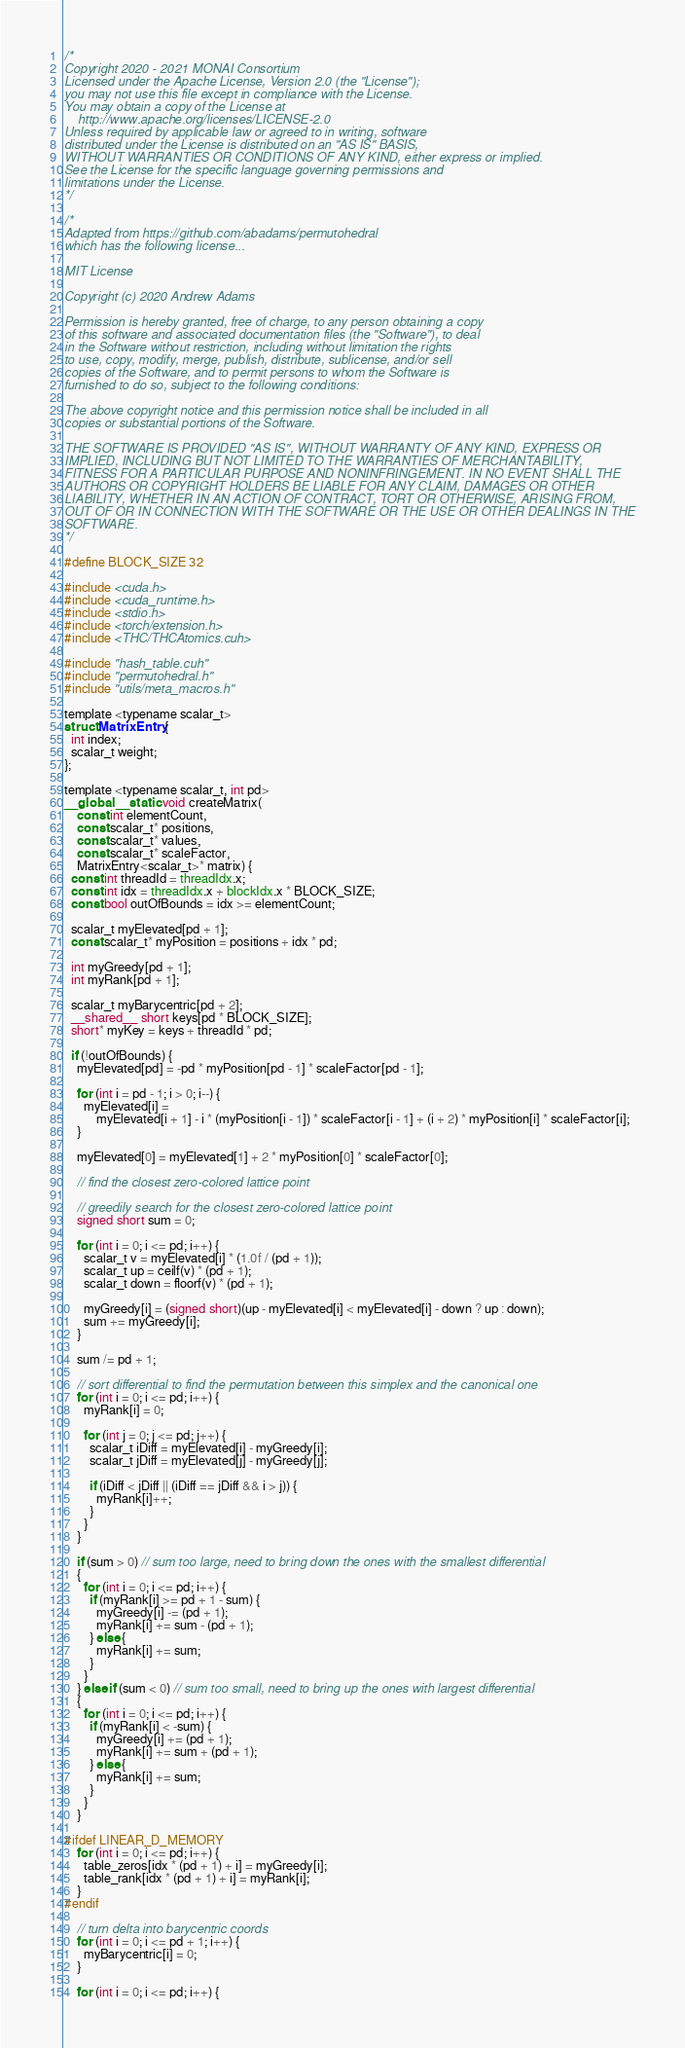<code> <loc_0><loc_0><loc_500><loc_500><_Cuda_>/*
Copyright 2020 - 2021 MONAI Consortium
Licensed under the Apache License, Version 2.0 (the "License");
you may not use this file except in compliance with the License.
You may obtain a copy of the License at
    http://www.apache.org/licenses/LICENSE-2.0
Unless required by applicable law or agreed to in writing, software
distributed under the License is distributed on an "AS IS" BASIS,
WITHOUT WARRANTIES OR CONDITIONS OF ANY KIND, either express or implied.
See the License for the specific language governing permissions and
limitations under the License.
*/

/*
Adapted from https://github.com/abadams/permutohedral
which has the following license...

MIT License

Copyright (c) 2020 Andrew Adams

Permission is hereby granted, free of charge, to any person obtaining a copy
of this software and associated documentation files (the "Software"), to deal
in the Software without restriction, including without limitation the rights
to use, copy, modify, merge, publish, distribute, sublicense, and/or sell
copies of the Software, and to permit persons to whom the Software is
furnished to do so, subject to the following conditions:

The above copyright notice and this permission notice shall be included in all
copies or substantial portions of the Software.

THE SOFTWARE IS PROVIDED "AS IS", WITHOUT WARRANTY OF ANY KIND, EXPRESS OR
IMPLIED, INCLUDING BUT NOT LIMITED TO THE WARRANTIES OF MERCHANTABILITY,
FITNESS FOR A PARTICULAR PURPOSE AND NONINFRINGEMENT. IN NO EVENT SHALL THE
AUTHORS OR COPYRIGHT HOLDERS BE LIABLE FOR ANY CLAIM, DAMAGES OR OTHER
LIABILITY, WHETHER IN AN ACTION OF CONTRACT, TORT OR OTHERWISE, ARISING FROM,
OUT OF OR IN CONNECTION WITH THE SOFTWARE OR THE USE OR OTHER DEALINGS IN THE
SOFTWARE.
*/

#define BLOCK_SIZE 32

#include <cuda.h>
#include <cuda_runtime.h>
#include <stdio.h>
#include <torch/extension.h>
#include <THC/THCAtomics.cuh>

#include "hash_table.cuh"
#include "permutohedral.h"
#include "utils/meta_macros.h"

template <typename scalar_t>
struct MatrixEntry {
  int index;
  scalar_t weight;
};

template <typename scalar_t, int pd>
__global__ static void createMatrix(
    const int elementCount,
    const scalar_t* positions,
    const scalar_t* values,
    const scalar_t* scaleFactor,
    MatrixEntry<scalar_t>* matrix) {
  const int threadId = threadIdx.x;
  const int idx = threadIdx.x + blockIdx.x * BLOCK_SIZE;
  const bool outOfBounds = idx >= elementCount;

  scalar_t myElevated[pd + 1];
  const scalar_t* myPosition = positions + idx * pd;

  int myGreedy[pd + 1];
  int myRank[pd + 1];

  scalar_t myBarycentric[pd + 2];
  __shared__ short keys[pd * BLOCK_SIZE];
  short* myKey = keys + threadId * pd;

  if (!outOfBounds) {
    myElevated[pd] = -pd * myPosition[pd - 1] * scaleFactor[pd - 1];

    for (int i = pd - 1; i > 0; i--) {
      myElevated[i] =
          myElevated[i + 1] - i * (myPosition[i - 1]) * scaleFactor[i - 1] + (i + 2) * myPosition[i] * scaleFactor[i];
    }

    myElevated[0] = myElevated[1] + 2 * myPosition[0] * scaleFactor[0];

    // find the closest zero-colored lattice point

    // greedily search for the closest zero-colored lattice point
    signed short sum = 0;

    for (int i = 0; i <= pd; i++) {
      scalar_t v = myElevated[i] * (1.0f / (pd + 1));
      scalar_t up = ceilf(v) * (pd + 1);
      scalar_t down = floorf(v) * (pd + 1);

      myGreedy[i] = (signed short)(up - myElevated[i] < myElevated[i] - down ? up : down);
      sum += myGreedy[i];
    }

    sum /= pd + 1;

    // sort differential to find the permutation between this simplex and the canonical one
    for (int i = 0; i <= pd; i++) {
      myRank[i] = 0;

      for (int j = 0; j <= pd; j++) {
        scalar_t iDiff = myElevated[i] - myGreedy[i];
        scalar_t jDiff = myElevated[j] - myGreedy[j];

        if (iDiff < jDiff || (iDiff == jDiff && i > j)) {
          myRank[i]++;
        }
      }
    }

    if (sum > 0) // sum too large, need to bring down the ones with the smallest differential
    {
      for (int i = 0; i <= pd; i++) {
        if (myRank[i] >= pd + 1 - sum) {
          myGreedy[i] -= (pd + 1);
          myRank[i] += sum - (pd + 1);
        } else {
          myRank[i] += sum;
        }
      }
    } else if (sum < 0) // sum too small, need to bring up the ones with largest differential
    {
      for (int i = 0; i <= pd; i++) {
        if (myRank[i] < -sum) {
          myGreedy[i] += (pd + 1);
          myRank[i] += sum + (pd + 1);
        } else {
          myRank[i] += sum;
        }
      }
    }

#ifdef LINEAR_D_MEMORY
    for (int i = 0; i <= pd; i++) {
      table_zeros[idx * (pd + 1) + i] = myGreedy[i];
      table_rank[idx * (pd + 1) + i] = myRank[i];
    }
#endif

    // turn delta into barycentric coords
    for (int i = 0; i <= pd + 1; i++) {
      myBarycentric[i] = 0;
    }

    for (int i = 0; i <= pd; i++) {</code> 